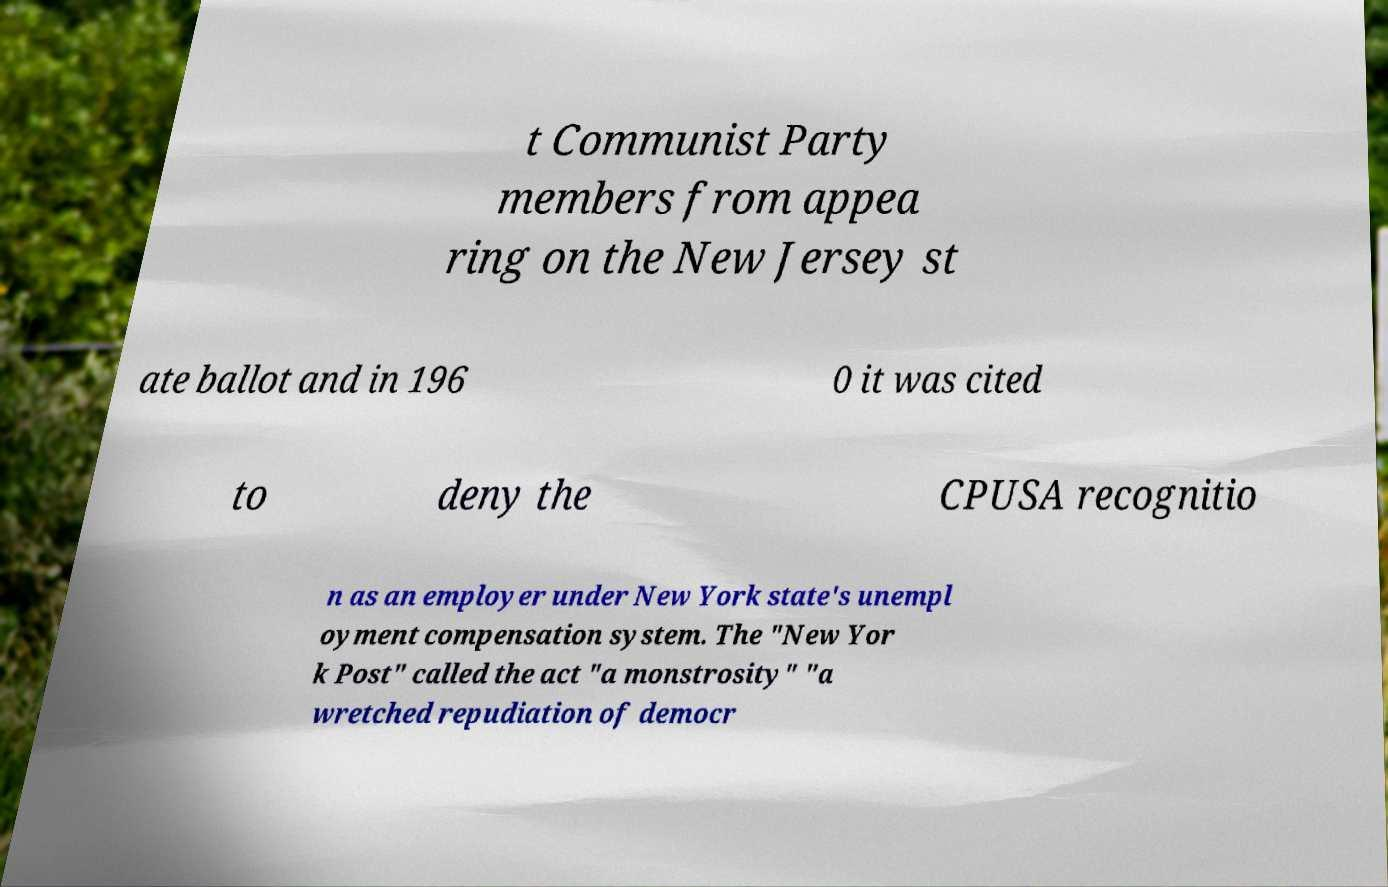Please read and relay the text visible in this image. What does it say? t Communist Party members from appea ring on the New Jersey st ate ballot and in 196 0 it was cited to deny the CPUSA recognitio n as an employer under New York state's unempl oyment compensation system. The "New Yor k Post" called the act "a monstrosity" "a wretched repudiation of democr 